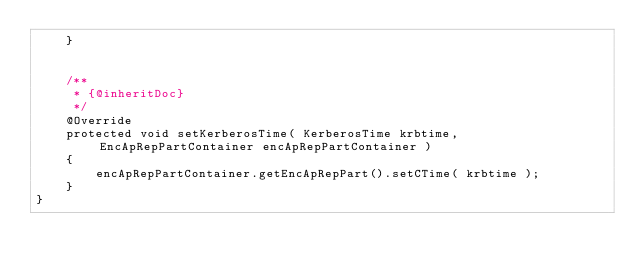<code> <loc_0><loc_0><loc_500><loc_500><_Java_>    }


    /**
     * {@inheritDoc}
     */
    @Override
    protected void setKerberosTime( KerberosTime krbtime, EncApRepPartContainer encApRepPartContainer )
    {
        encApRepPartContainer.getEncApRepPart().setCTime( krbtime );
    }
}
</code> 